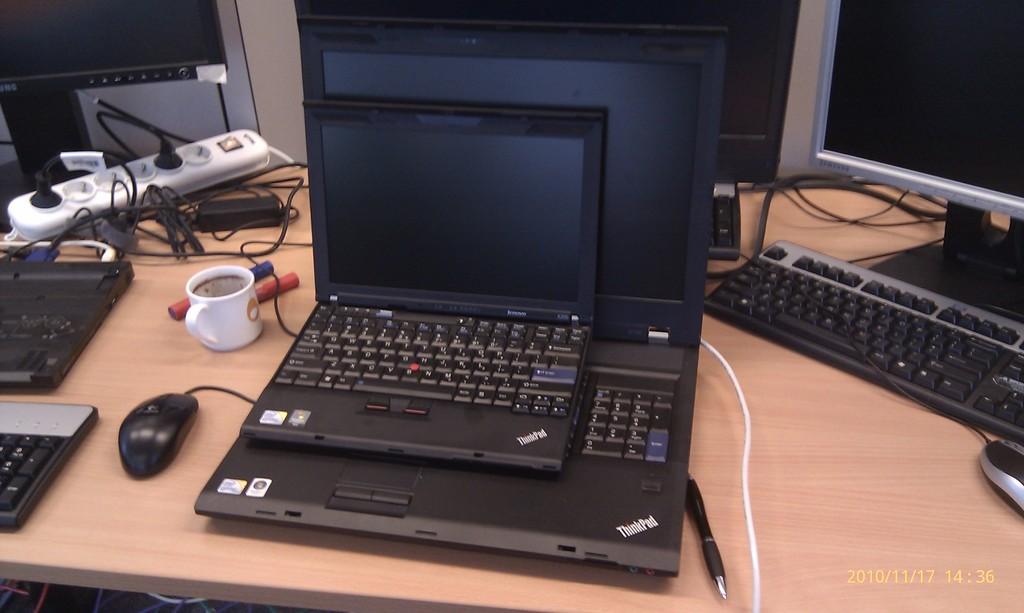What type of computer is that?
Give a very brief answer. Thinkpad. What brand is this computer?
Offer a terse response. Thinkpad. 